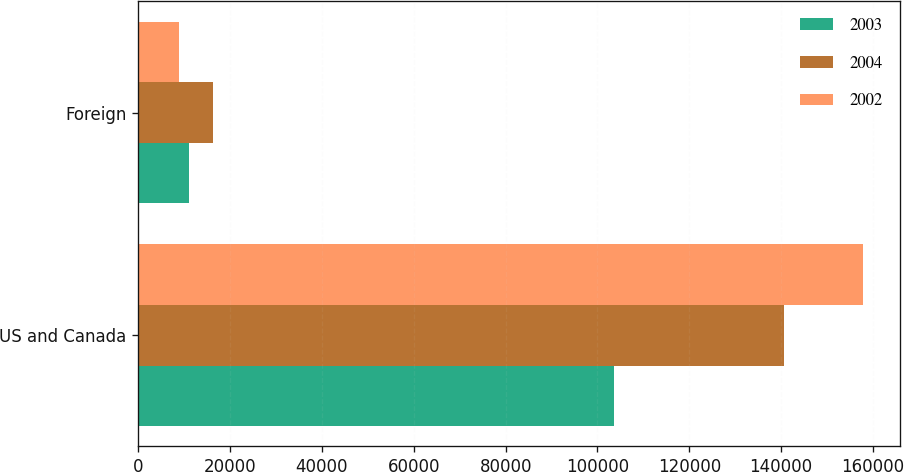Convert chart to OTSL. <chart><loc_0><loc_0><loc_500><loc_500><stacked_bar_chart><ecel><fcel>US and Canada<fcel>Foreign<nl><fcel>2003<fcel>103561<fcel>10958<nl><fcel>2004<fcel>140638<fcel>16351<nl><fcel>2002<fcel>157929<fcel>8806<nl></chart> 